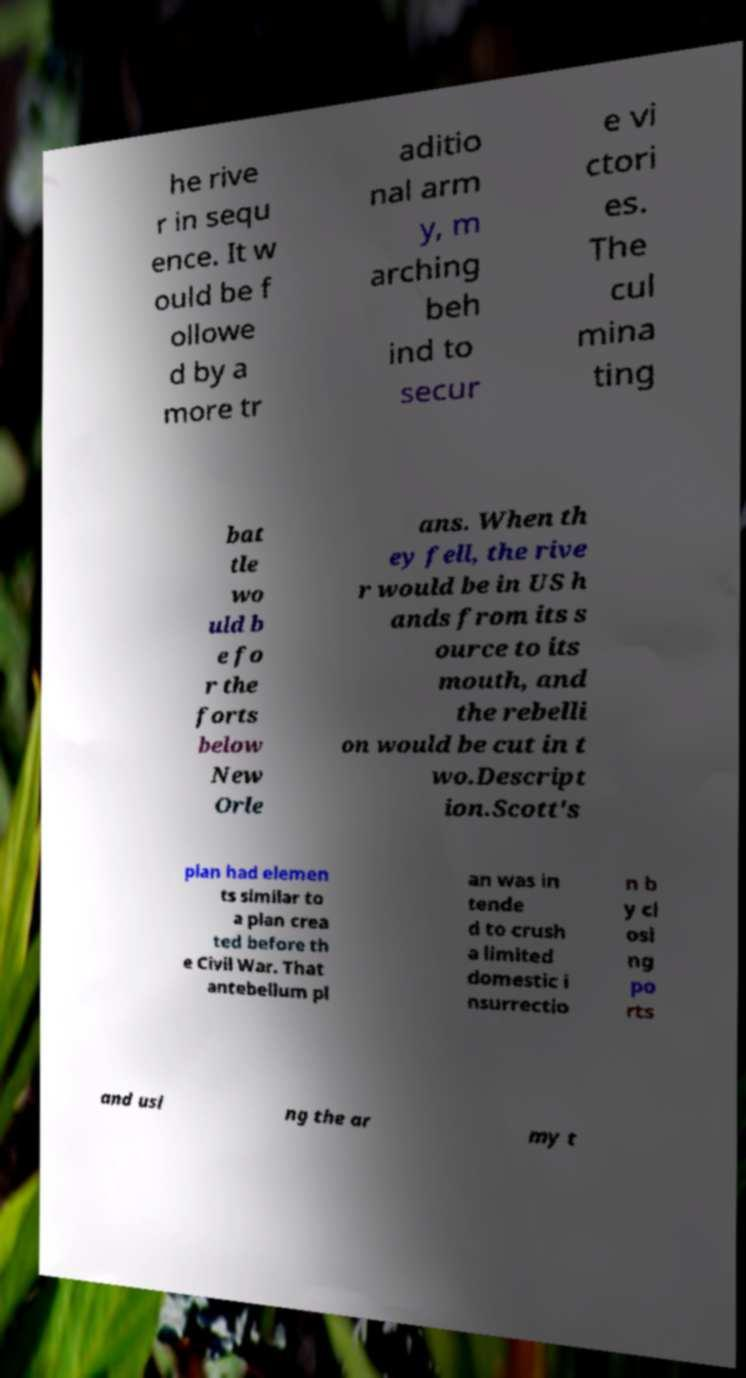Can you read and provide the text displayed in the image?This photo seems to have some interesting text. Can you extract and type it out for me? he rive r in sequ ence. It w ould be f ollowe d by a more tr aditio nal arm y, m arching beh ind to secur e vi ctori es. The cul mina ting bat tle wo uld b e fo r the forts below New Orle ans. When th ey fell, the rive r would be in US h ands from its s ource to its mouth, and the rebelli on would be cut in t wo.Descript ion.Scott's plan had elemen ts similar to a plan crea ted before th e Civil War. That antebellum pl an was in tende d to crush a limited domestic i nsurrectio n b y cl osi ng po rts and usi ng the ar my t 